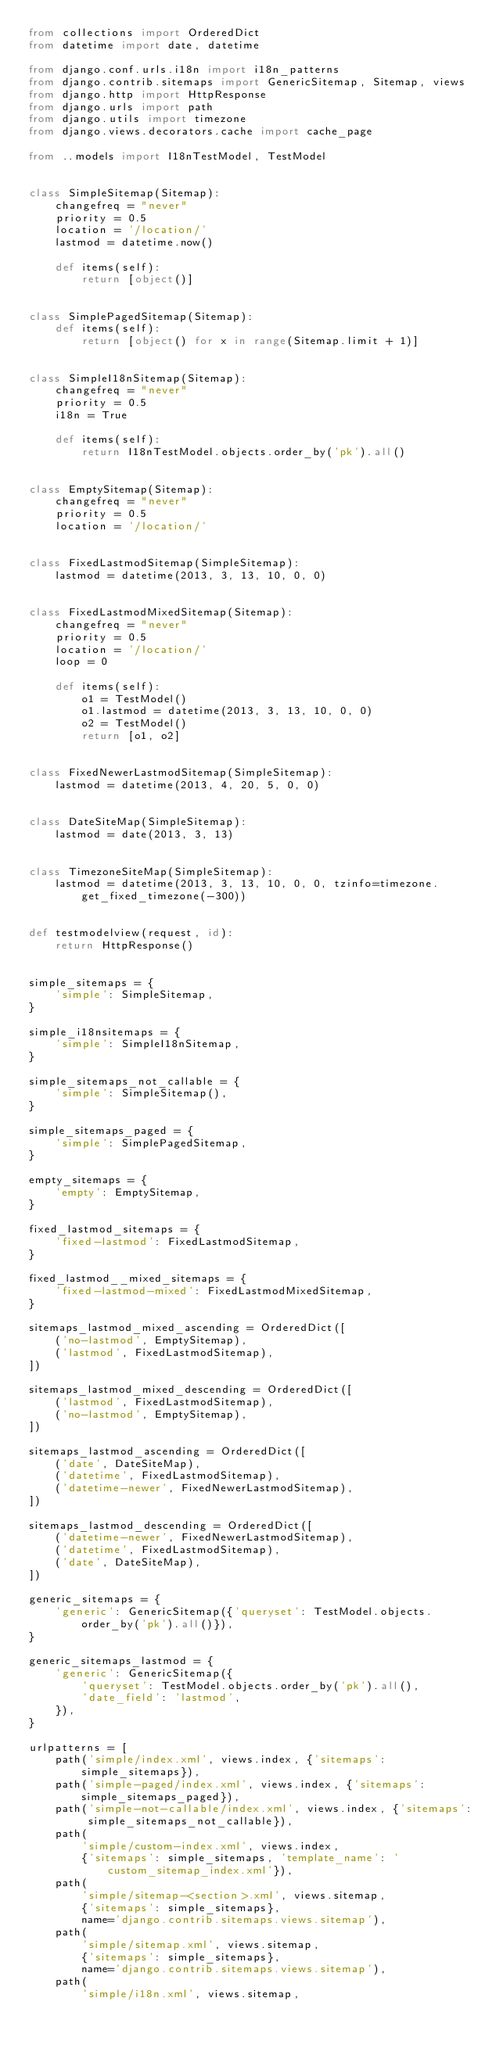Convert code to text. <code><loc_0><loc_0><loc_500><loc_500><_Python_>from collections import OrderedDict
from datetime import date, datetime

from django.conf.urls.i18n import i18n_patterns
from django.contrib.sitemaps import GenericSitemap, Sitemap, views
from django.http import HttpResponse
from django.urls import path
from django.utils import timezone
from django.views.decorators.cache import cache_page

from ..models import I18nTestModel, TestModel


class SimpleSitemap(Sitemap):
    changefreq = "never"
    priority = 0.5
    location = '/location/'
    lastmod = datetime.now()

    def items(self):
        return [object()]


class SimplePagedSitemap(Sitemap):
    def items(self):
        return [object() for x in range(Sitemap.limit + 1)]


class SimpleI18nSitemap(Sitemap):
    changefreq = "never"
    priority = 0.5
    i18n = True

    def items(self):
        return I18nTestModel.objects.order_by('pk').all()


class EmptySitemap(Sitemap):
    changefreq = "never"
    priority = 0.5
    location = '/location/'


class FixedLastmodSitemap(SimpleSitemap):
    lastmod = datetime(2013, 3, 13, 10, 0, 0)


class FixedLastmodMixedSitemap(Sitemap):
    changefreq = "never"
    priority = 0.5
    location = '/location/'
    loop = 0

    def items(self):
        o1 = TestModel()
        o1.lastmod = datetime(2013, 3, 13, 10, 0, 0)
        o2 = TestModel()
        return [o1, o2]


class FixedNewerLastmodSitemap(SimpleSitemap):
    lastmod = datetime(2013, 4, 20, 5, 0, 0)


class DateSiteMap(SimpleSitemap):
    lastmod = date(2013, 3, 13)


class TimezoneSiteMap(SimpleSitemap):
    lastmod = datetime(2013, 3, 13, 10, 0, 0, tzinfo=timezone.get_fixed_timezone(-300))


def testmodelview(request, id):
    return HttpResponse()


simple_sitemaps = {
    'simple': SimpleSitemap,
}

simple_i18nsitemaps = {
    'simple': SimpleI18nSitemap,
}

simple_sitemaps_not_callable = {
    'simple': SimpleSitemap(),
}

simple_sitemaps_paged = {
    'simple': SimplePagedSitemap,
}

empty_sitemaps = {
    'empty': EmptySitemap,
}

fixed_lastmod_sitemaps = {
    'fixed-lastmod': FixedLastmodSitemap,
}

fixed_lastmod__mixed_sitemaps = {
    'fixed-lastmod-mixed': FixedLastmodMixedSitemap,
}

sitemaps_lastmod_mixed_ascending = OrderedDict([
    ('no-lastmod', EmptySitemap),
    ('lastmod', FixedLastmodSitemap),
])

sitemaps_lastmod_mixed_descending = OrderedDict([
    ('lastmod', FixedLastmodSitemap),
    ('no-lastmod', EmptySitemap),
])

sitemaps_lastmod_ascending = OrderedDict([
    ('date', DateSiteMap),
    ('datetime', FixedLastmodSitemap),
    ('datetime-newer', FixedNewerLastmodSitemap),
])

sitemaps_lastmod_descending = OrderedDict([
    ('datetime-newer', FixedNewerLastmodSitemap),
    ('datetime', FixedLastmodSitemap),
    ('date', DateSiteMap),
])

generic_sitemaps = {
    'generic': GenericSitemap({'queryset': TestModel.objects.order_by('pk').all()}),
}

generic_sitemaps_lastmod = {
    'generic': GenericSitemap({
        'queryset': TestModel.objects.order_by('pk').all(),
        'date_field': 'lastmod',
    }),
}

urlpatterns = [
    path('simple/index.xml', views.index, {'sitemaps': simple_sitemaps}),
    path('simple-paged/index.xml', views.index, {'sitemaps': simple_sitemaps_paged}),
    path('simple-not-callable/index.xml', views.index, {'sitemaps': simple_sitemaps_not_callable}),
    path(
        'simple/custom-index.xml', views.index,
        {'sitemaps': simple_sitemaps, 'template_name': 'custom_sitemap_index.xml'}),
    path(
        'simple/sitemap-<section>.xml', views.sitemap,
        {'sitemaps': simple_sitemaps},
        name='django.contrib.sitemaps.views.sitemap'),
    path(
        'simple/sitemap.xml', views.sitemap,
        {'sitemaps': simple_sitemaps},
        name='django.contrib.sitemaps.views.sitemap'),
    path(
        'simple/i18n.xml', views.sitemap,</code> 